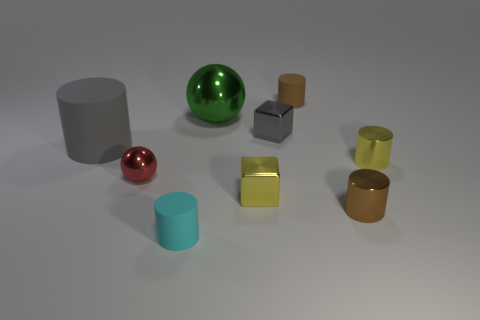Subtract all gray cylinders. How many cylinders are left? 4 Subtract all tiny yellow cylinders. How many cylinders are left? 4 Subtract all red cylinders. Subtract all red balls. How many cylinders are left? 5 Subtract all cubes. How many objects are left? 7 Add 3 tiny spheres. How many tiny spheres exist? 4 Subtract 0 purple cubes. How many objects are left? 9 Subtract all cyan rubber blocks. Subtract all yellow cubes. How many objects are left? 8 Add 3 metal objects. How many metal objects are left? 9 